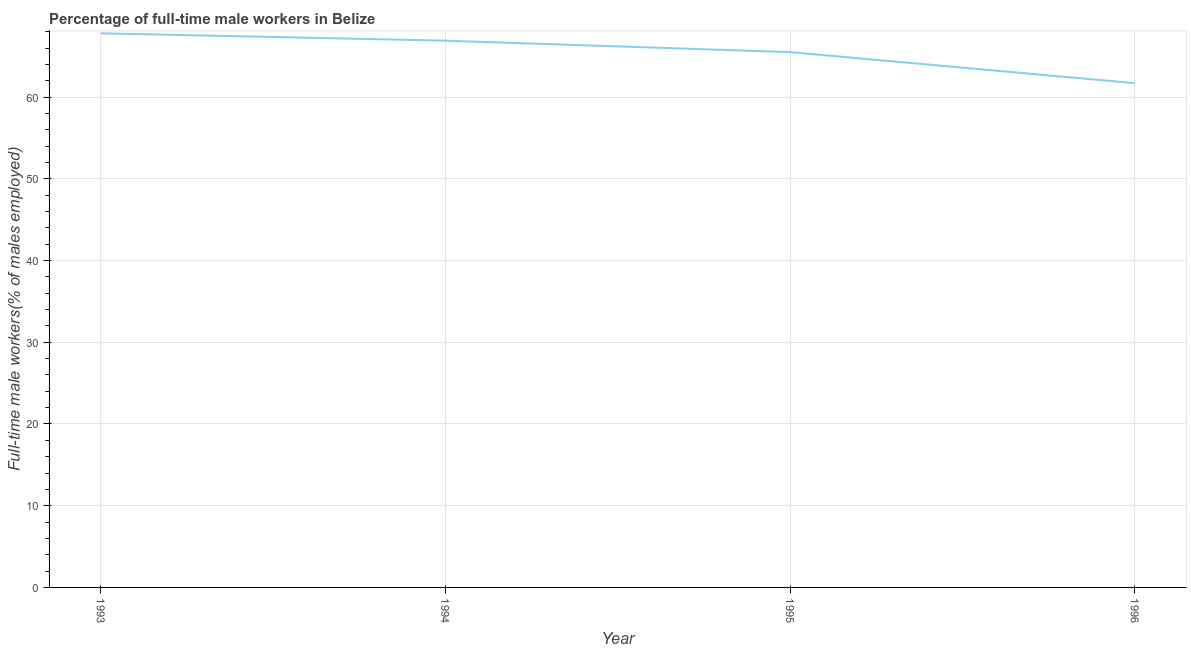What is the percentage of full-time male workers in 1995?
Offer a very short reply. 65.5. Across all years, what is the maximum percentage of full-time male workers?
Provide a short and direct response. 67.8. Across all years, what is the minimum percentage of full-time male workers?
Keep it short and to the point. 61.7. In which year was the percentage of full-time male workers maximum?
Your answer should be compact. 1993. What is the sum of the percentage of full-time male workers?
Give a very brief answer. 261.9. What is the difference between the percentage of full-time male workers in 1994 and 1996?
Your response must be concise. 5.2. What is the average percentage of full-time male workers per year?
Offer a terse response. 65.48. What is the median percentage of full-time male workers?
Your answer should be compact. 66.2. In how many years, is the percentage of full-time male workers greater than 6 %?
Provide a succinct answer. 4. Do a majority of the years between 1996 and 1994 (inclusive) have percentage of full-time male workers greater than 30 %?
Offer a very short reply. No. What is the ratio of the percentage of full-time male workers in 1994 to that in 1996?
Offer a very short reply. 1.08. What is the difference between the highest and the second highest percentage of full-time male workers?
Offer a terse response. 0.9. What is the difference between the highest and the lowest percentage of full-time male workers?
Your answer should be very brief. 6.1. How many lines are there?
Your answer should be compact. 1. Does the graph contain grids?
Your answer should be compact. Yes. What is the title of the graph?
Offer a very short reply. Percentage of full-time male workers in Belize. What is the label or title of the Y-axis?
Your answer should be compact. Full-time male workers(% of males employed). What is the Full-time male workers(% of males employed) of 1993?
Offer a very short reply. 67.8. What is the Full-time male workers(% of males employed) of 1994?
Ensure brevity in your answer.  66.9. What is the Full-time male workers(% of males employed) of 1995?
Make the answer very short. 65.5. What is the Full-time male workers(% of males employed) of 1996?
Provide a short and direct response. 61.7. What is the difference between the Full-time male workers(% of males employed) in 1993 and 1994?
Provide a short and direct response. 0.9. What is the difference between the Full-time male workers(% of males employed) in 1993 and 1995?
Provide a succinct answer. 2.3. What is the difference between the Full-time male workers(% of males employed) in 1993 and 1996?
Your answer should be very brief. 6.1. What is the difference between the Full-time male workers(% of males employed) in 1994 and 1995?
Keep it short and to the point. 1.4. What is the difference between the Full-time male workers(% of males employed) in 1994 and 1996?
Provide a succinct answer. 5.2. What is the ratio of the Full-time male workers(% of males employed) in 1993 to that in 1994?
Keep it short and to the point. 1.01. What is the ratio of the Full-time male workers(% of males employed) in 1993 to that in 1995?
Your answer should be compact. 1.03. What is the ratio of the Full-time male workers(% of males employed) in 1993 to that in 1996?
Offer a terse response. 1.1. What is the ratio of the Full-time male workers(% of males employed) in 1994 to that in 1996?
Keep it short and to the point. 1.08. What is the ratio of the Full-time male workers(% of males employed) in 1995 to that in 1996?
Give a very brief answer. 1.06. 